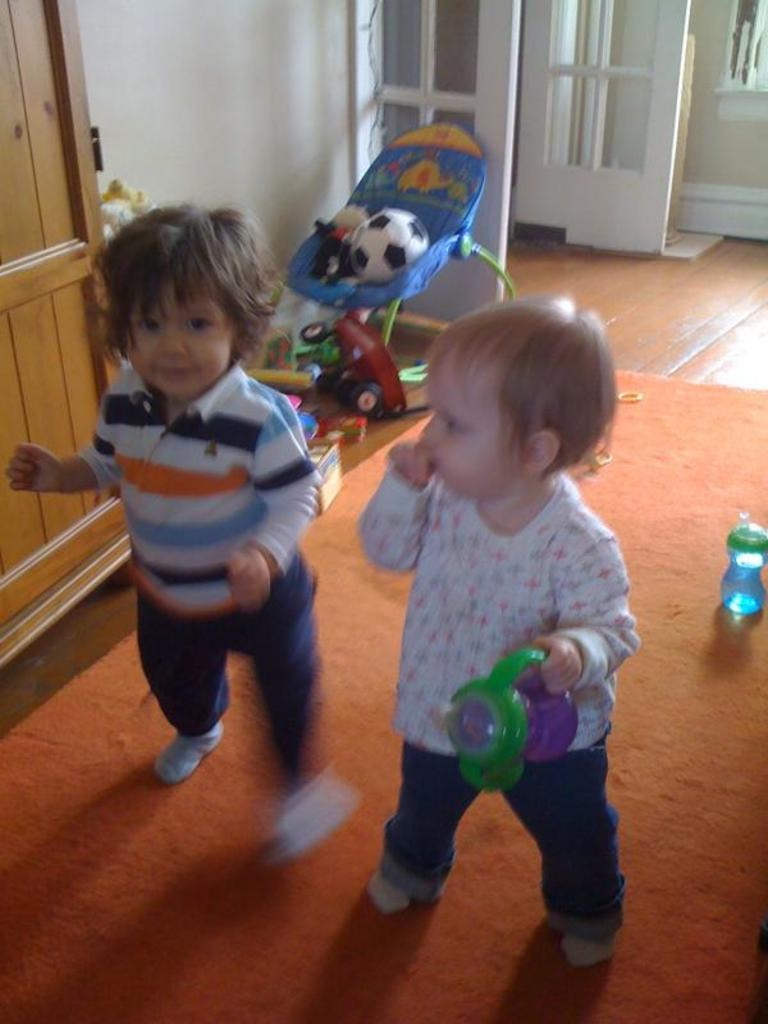How many children are present in the image? There are two children in the image. What are the children standing on? The children are standing on a mat. What objects can be seen in the image besides the children? There is a bottle and a ball in the image. What can be seen in the background of the image? There is a trolley on the floor in the background of the image. What flavor of breakfast is the children eating in the image? There is no breakfast present in the image, so it is not possible to determine the flavor. 